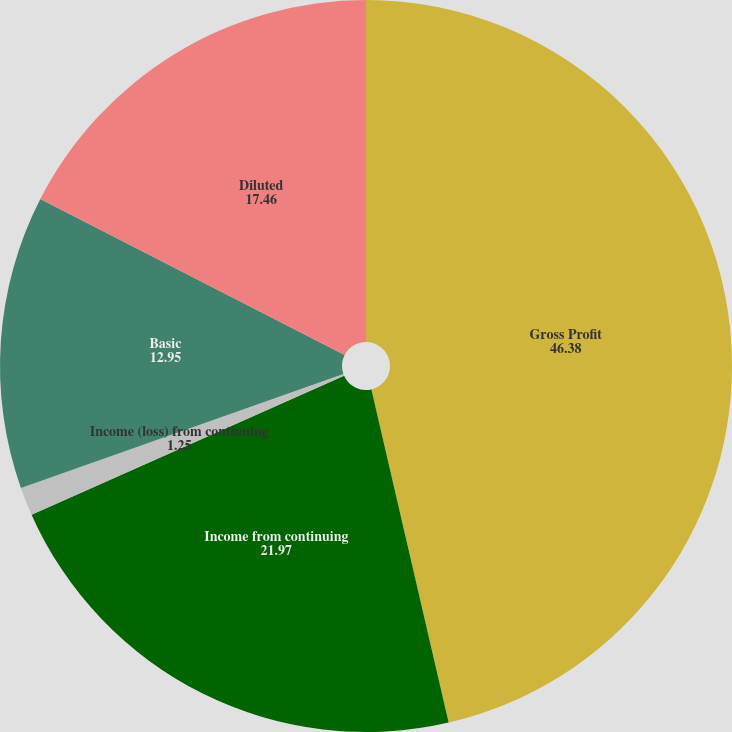<chart> <loc_0><loc_0><loc_500><loc_500><pie_chart><fcel>Gross Profit<fcel>Income from continuing<fcel>Income (loss) from continuing<fcel>Basic<fcel>Diluted<nl><fcel>46.38%<fcel>21.97%<fcel>1.25%<fcel>12.95%<fcel>17.46%<nl></chart> 